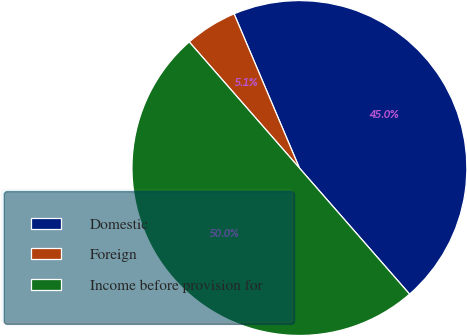Convert chart. <chart><loc_0><loc_0><loc_500><loc_500><pie_chart><fcel>Domestic<fcel>Foreign<fcel>Income before provision for<nl><fcel>44.95%<fcel>5.05%<fcel>50.0%<nl></chart> 